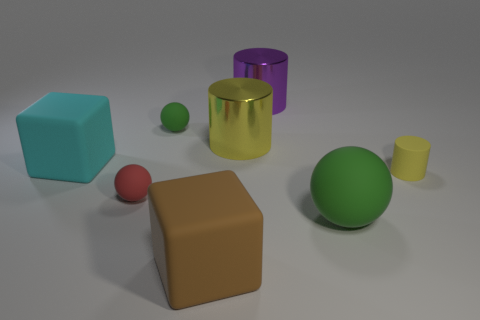Add 2 large purple things. How many objects exist? 10 Subtract all cylinders. How many objects are left? 5 Add 4 large purple metal objects. How many large purple metal objects are left? 5 Add 3 small yellow cubes. How many small yellow cubes exist? 3 Subtract 0 green cylinders. How many objects are left? 8 Subtract all big brown rubber balls. Subtract all small red objects. How many objects are left? 7 